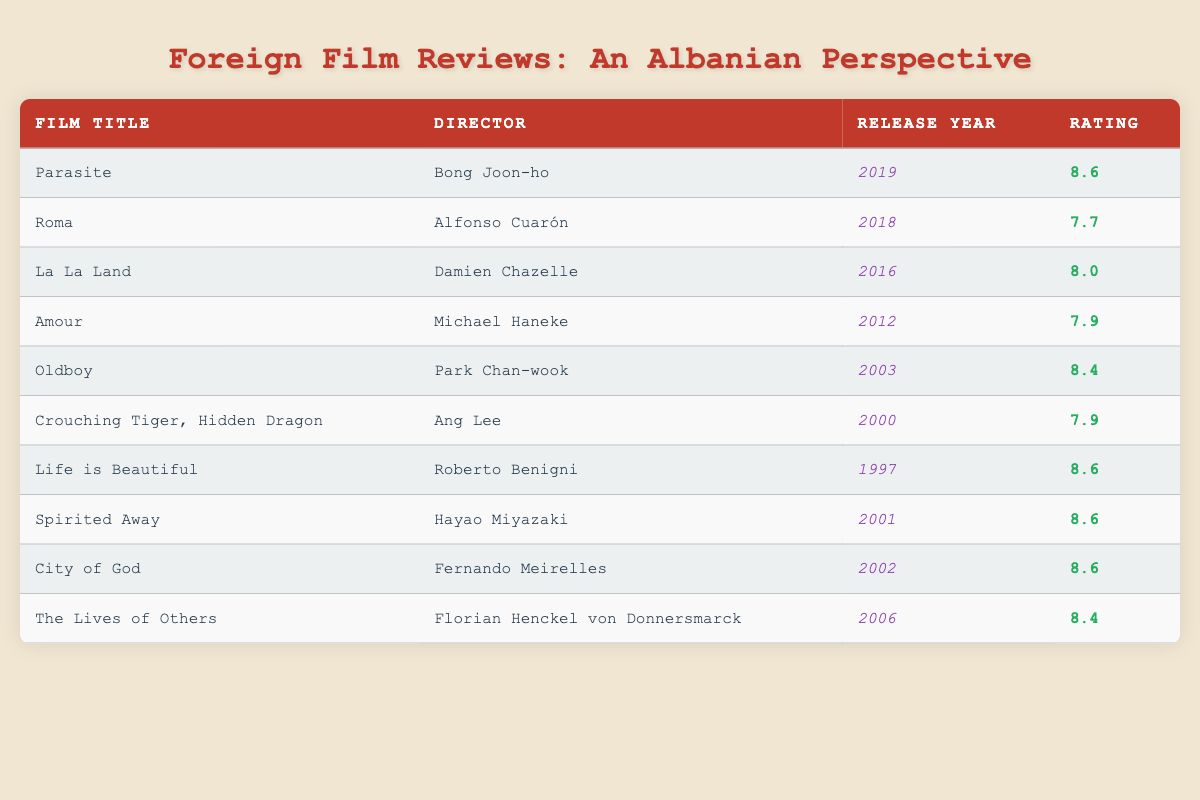What is the highest rated film in the table? The ratings for all films are listed in the table. By scanning the "Rating" column, we see "Parasite," "Life is Beautiful," "Spirited Away," and "City of God" all have the highest rating of 8.6.
Answer: 8.6 How many films were released after the year 2000? Looking at the "Release Year" column, the films that were released after 2000 are "Oldboy" (2003), "The Lives of Others" (2006), "Roma" (2018), and "Parasite" (2019). Counting these gives us a total of 4 films.
Answer: 4 Which film has a rating less than 8 but was released after 2010? We check the films released after 2010, which are "Roma" (2018) with a rating of 7.7. This is the only film that meets both conditions.
Answer: Roma What is the average rating of films released in the 21st century (2000 and onward)? The films released in the 21st century are "Crouching Tiger, Hidden Dragon" (7.9), "Spirited Away" (8.6), "City of God" (8.6), "Oldboy" (8.4), "The Lives of Others" (8.4), "Roma" (7.7), and "Parasite" (8.6). There are 7 films, and we calculate their total rating: 7.9 + 8.6 + 8.6 + 8.4 + 8.4 + 7.7 + 8.6 = 58.2. Now we find the average: 58.2 / 7 = approximately 8.31.
Answer: 8.31 Is there a film directed by Hayao Miyazaki in this table? We look through the "Director" column and find "Spirited Away," which was directed by Hayao Miyazaki. Therefore, the answer is yes.
Answer: Yes 